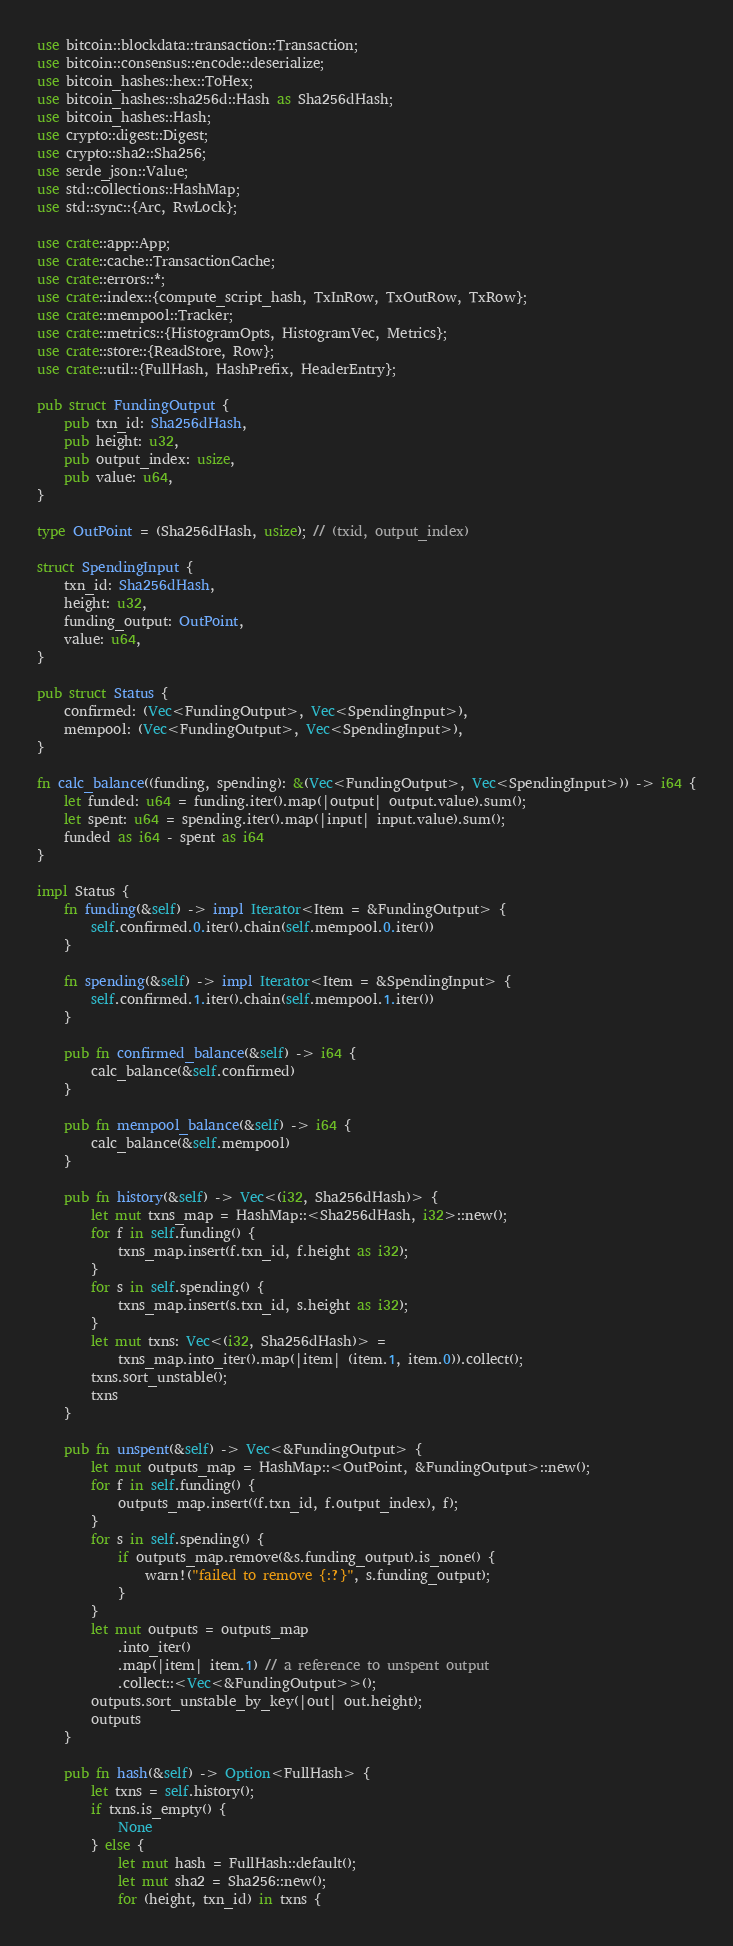Convert code to text. <code><loc_0><loc_0><loc_500><loc_500><_Rust_>use bitcoin::blockdata::transaction::Transaction;
use bitcoin::consensus::encode::deserialize;
use bitcoin_hashes::hex::ToHex;
use bitcoin_hashes::sha256d::Hash as Sha256dHash;
use bitcoin_hashes::Hash;
use crypto::digest::Digest;
use crypto::sha2::Sha256;
use serde_json::Value;
use std::collections::HashMap;
use std::sync::{Arc, RwLock};

use crate::app::App;
use crate::cache::TransactionCache;
use crate::errors::*;
use crate::index::{compute_script_hash, TxInRow, TxOutRow, TxRow};
use crate::mempool::Tracker;
use crate::metrics::{HistogramOpts, HistogramVec, Metrics};
use crate::store::{ReadStore, Row};
use crate::util::{FullHash, HashPrefix, HeaderEntry};

pub struct FundingOutput {
    pub txn_id: Sha256dHash,
    pub height: u32,
    pub output_index: usize,
    pub value: u64,
}

type OutPoint = (Sha256dHash, usize); // (txid, output_index)

struct SpendingInput {
    txn_id: Sha256dHash,
    height: u32,
    funding_output: OutPoint,
    value: u64,
}

pub struct Status {
    confirmed: (Vec<FundingOutput>, Vec<SpendingInput>),
    mempool: (Vec<FundingOutput>, Vec<SpendingInput>),
}

fn calc_balance((funding, spending): &(Vec<FundingOutput>, Vec<SpendingInput>)) -> i64 {
    let funded: u64 = funding.iter().map(|output| output.value).sum();
    let spent: u64 = spending.iter().map(|input| input.value).sum();
    funded as i64 - spent as i64
}

impl Status {
    fn funding(&self) -> impl Iterator<Item = &FundingOutput> {
        self.confirmed.0.iter().chain(self.mempool.0.iter())
    }

    fn spending(&self) -> impl Iterator<Item = &SpendingInput> {
        self.confirmed.1.iter().chain(self.mempool.1.iter())
    }

    pub fn confirmed_balance(&self) -> i64 {
        calc_balance(&self.confirmed)
    }

    pub fn mempool_balance(&self) -> i64 {
        calc_balance(&self.mempool)
    }

    pub fn history(&self) -> Vec<(i32, Sha256dHash)> {
        let mut txns_map = HashMap::<Sha256dHash, i32>::new();
        for f in self.funding() {
            txns_map.insert(f.txn_id, f.height as i32);
        }
        for s in self.spending() {
            txns_map.insert(s.txn_id, s.height as i32);
        }
        let mut txns: Vec<(i32, Sha256dHash)> =
            txns_map.into_iter().map(|item| (item.1, item.0)).collect();
        txns.sort_unstable();
        txns
    }

    pub fn unspent(&self) -> Vec<&FundingOutput> {
        let mut outputs_map = HashMap::<OutPoint, &FundingOutput>::new();
        for f in self.funding() {
            outputs_map.insert((f.txn_id, f.output_index), f);
        }
        for s in self.spending() {
            if outputs_map.remove(&s.funding_output).is_none() {
                warn!("failed to remove {:?}", s.funding_output);
            }
        }
        let mut outputs = outputs_map
            .into_iter()
            .map(|item| item.1) // a reference to unspent output
            .collect::<Vec<&FundingOutput>>();
        outputs.sort_unstable_by_key(|out| out.height);
        outputs
    }

    pub fn hash(&self) -> Option<FullHash> {
        let txns = self.history();
        if txns.is_empty() {
            None
        } else {
            let mut hash = FullHash::default();
            let mut sha2 = Sha256::new();
            for (height, txn_id) in txns {</code> 